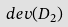<formula> <loc_0><loc_0><loc_500><loc_500>d e v ( D _ { 2 } )</formula> 